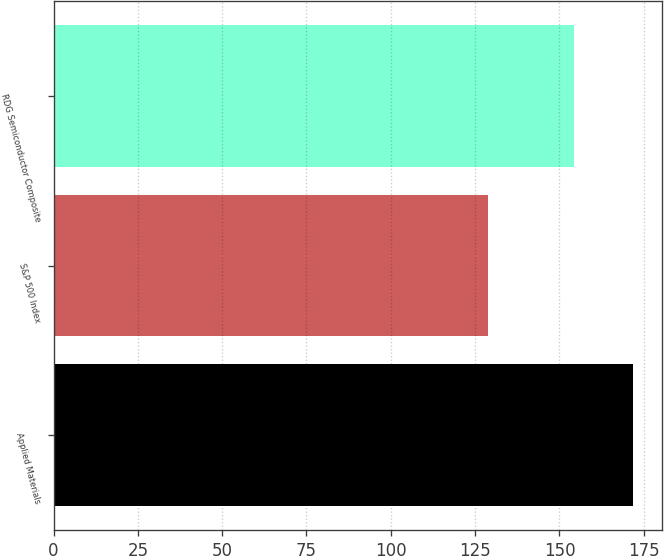Convert chart. <chart><loc_0><loc_0><loc_500><loc_500><bar_chart><fcel>Applied Materials<fcel>S&P 500 Index<fcel>RDG Semiconductor Composite<nl><fcel>171.69<fcel>128.93<fcel>154.41<nl></chart> 